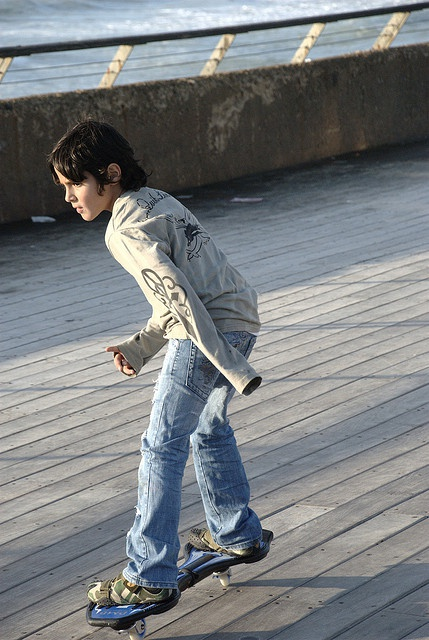Describe the objects in this image and their specific colors. I can see people in darkgray, gray, black, and ivory tones and skateboard in darkgray, black, and gray tones in this image. 